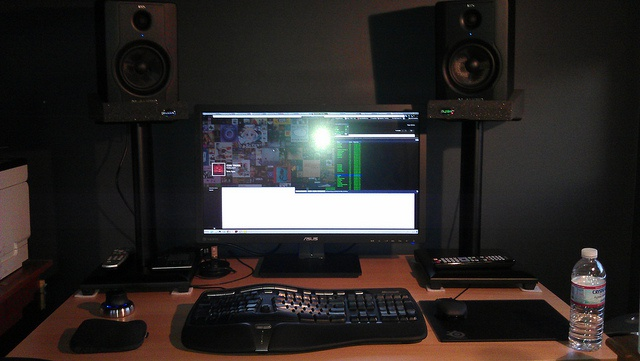Describe the objects in this image and their specific colors. I can see tv in black, white, gray, and navy tones, keyboard in black, navy, gray, and maroon tones, bottle in black, gray, and darkgray tones, remote in black, gray, and maroon tones, and mouse in black, maroon, and brown tones in this image. 